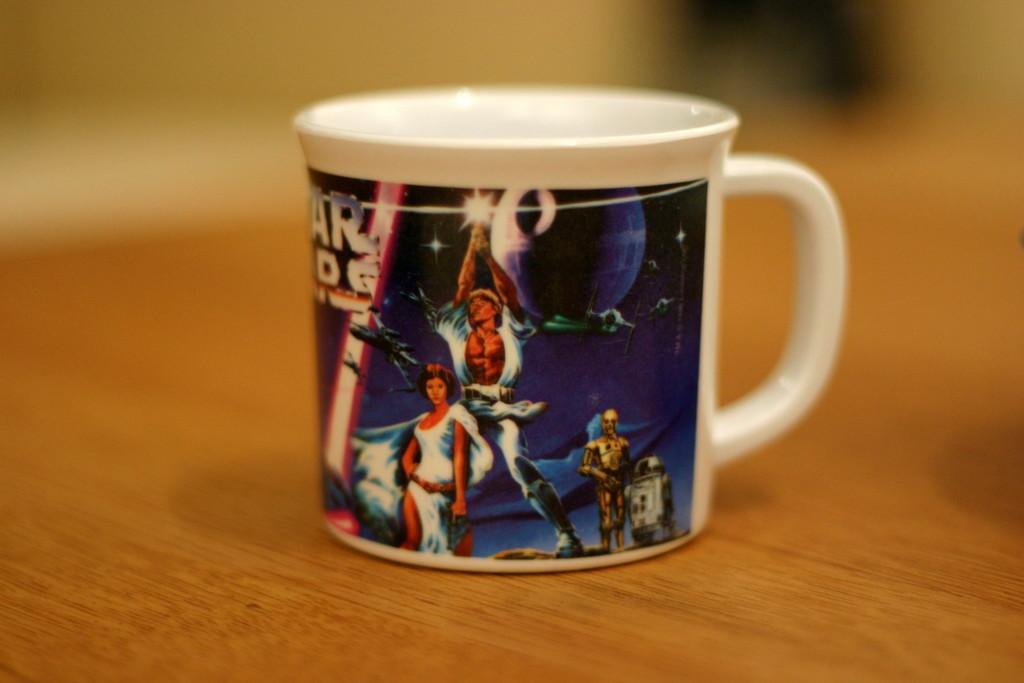Please provide a concise description of this image. In the image on the wooden surface there is a cup. On the cup there are images and also there is text on it. 